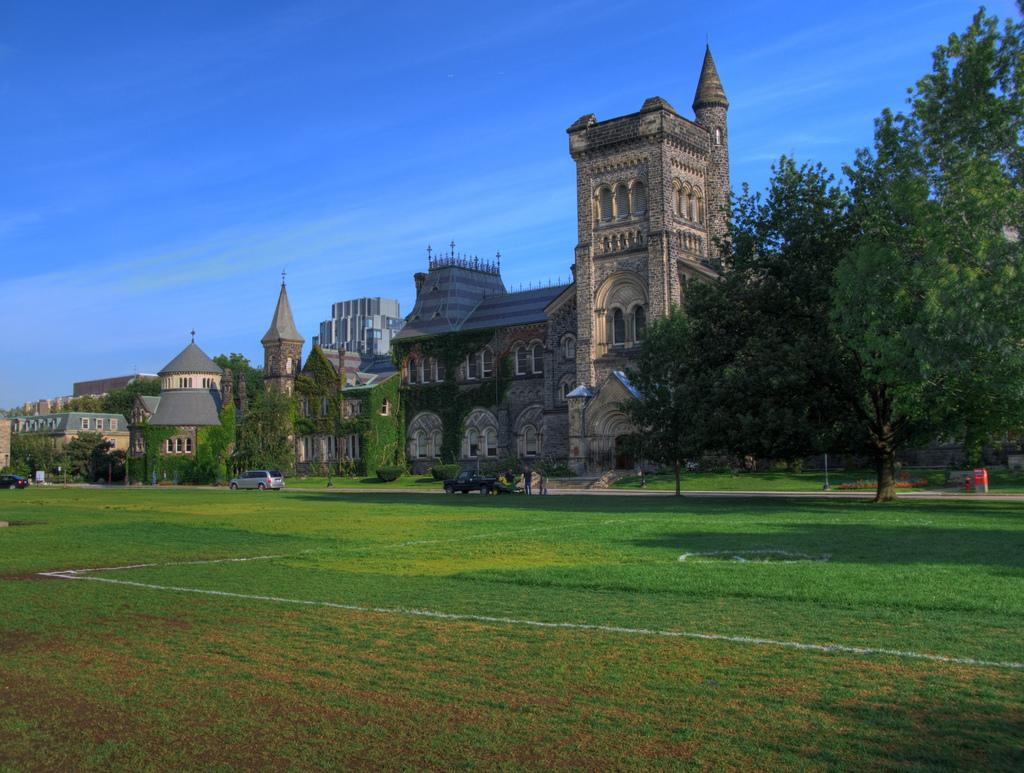What type of natural environment is visible in the image? There is grass and trees in the image. What type of structures can be seen in the image? There are buildings in the image. What type of objects are present in the image? Metal rods are visible in the image. What type of transportation is visible in the image? Vehicles are visible in the image. Can you describe the group of people in the image? There is a group of people beside a car in the middle of the image. Where is the throne located in the image? There is no throne present in the image. What type of material is the iron door made of in the image? There is no iron door present in the image. 